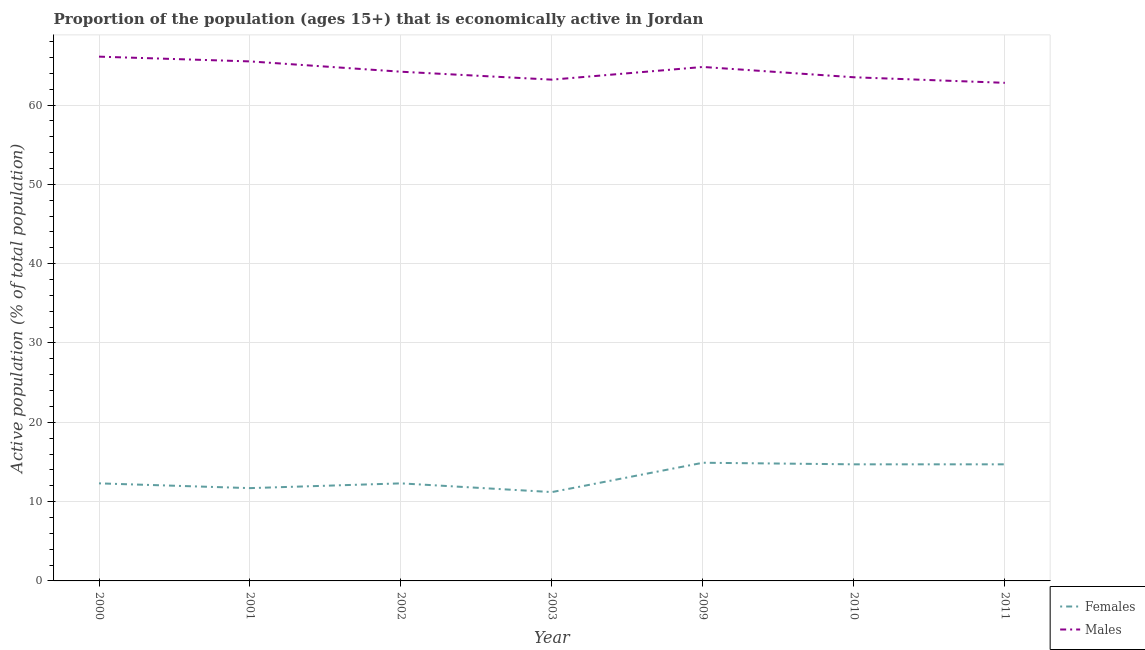How many different coloured lines are there?
Your answer should be compact. 2. What is the percentage of economically active female population in 2009?
Keep it short and to the point. 14.9. Across all years, what is the maximum percentage of economically active male population?
Give a very brief answer. 66.1. Across all years, what is the minimum percentage of economically active female population?
Offer a very short reply. 11.2. In which year was the percentage of economically active female population maximum?
Provide a succinct answer. 2009. What is the total percentage of economically active male population in the graph?
Ensure brevity in your answer.  450.1. What is the difference between the percentage of economically active male population in 2002 and that in 2011?
Offer a very short reply. 1.4. What is the difference between the percentage of economically active female population in 2011 and the percentage of economically active male population in 2009?
Offer a very short reply. -50.1. What is the average percentage of economically active male population per year?
Make the answer very short. 64.3. In the year 2009, what is the difference between the percentage of economically active female population and percentage of economically active male population?
Give a very brief answer. -49.9. What is the ratio of the percentage of economically active female population in 2000 to that in 2011?
Offer a terse response. 0.84. Is the difference between the percentage of economically active female population in 2009 and 2010 greater than the difference between the percentage of economically active male population in 2009 and 2010?
Your answer should be compact. No. What is the difference between the highest and the second highest percentage of economically active female population?
Your response must be concise. 0.2. What is the difference between the highest and the lowest percentage of economically active male population?
Offer a very short reply. 3.3. Is the sum of the percentage of economically active female population in 2000 and 2011 greater than the maximum percentage of economically active male population across all years?
Offer a terse response. No. Does the percentage of economically active female population monotonically increase over the years?
Offer a terse response. No. Is the percentage of economically active male population strictly greater than the percentage of economically active female population over the years?
Your answer should be very brief. Yes. Does the graph contain grids?
Ensure brevity in your answer.  Yes. Where does the legend appear in the graph?
Make the answer very short. Bottom right. How are the legend labels stacked?
Your response must be concise. Vertical. What is the title of the graph?
Make the answer very short. Proportion of the population (ages 15+) that is economically active in Jordan. Does "Start a business" appear as one of the legend labels in the graph?
Keep it short and to the point. No. What is the label or title of the Y-axis?
Give a very brief answer. Active population (% of total population). What is the Active population (% of total population) of Females in 2000?
Offer a very short reply. 12.3. What is the Active population (% of total population) in Males in 2000?
Your answer should be very brief. 66.1. What is the Active population (% of total population) of Females in 2001?
Your answer should be very brief. 11.7. What is the Active population (% of total population) of Males in 2001?
Make the answer very short. 65.5. What is the Active population (% of total population) of Females in 2002?
Provide a succinct answer. 12.3. What is the Active population (% of total population) in Males in 2002?
Your response must be concise. 64.2. What is the Active population (% of total population) in Females in 2003?
Your answer should be compact. 11.2. What is the Active population (% of total population) in Males in 2003?
Provide a short and direct response. 63.2. What is the Active population (% of total population) in Females in 2009?
Provide a succinct answer. 14.9. What is the Active population (% of total population) in Males in 2009?
Offer a terse response. 64.8. What is the Active population (% of total population) in Females in 2010?
Your answer should be very brief. 14.7. What is the Active population (% of total population) in Males in 2010?
Your response must be concise. 63.5. What is the Active population (% of total population) of Females in 2011?
Your answer should be very brief. 14.7. What is the Active population (% of total population) in Males in 2011?
Keep it short and to the point. 62.8. Across all years, what is the maximum Active population (% of total population) of Females?
Keep it short and to the point. 14.9. Across all years, what is the maximum Active population (% of total population) in Males?
Make the answer very short. 66.1. Across all years, what is the minimum Active population (% of total population) in Females?
Your answer should be compact. 11.2. Across all years, what is the minimum Active population (% of total population) of Males?
Your answer should be compact. 62.8. What is the total Active population (% of total population) in Females in the graph?
Give a very brief answer. 91.8. What is the total Active population (% of total population) in Males in the graph?
Your answer should be very brief. 450.1. What is the difference between the Active population (% of total population) of Males in 2000 and that in 2001?
Offer a very short reply. 0.6. What is the difference between the Active population (% of total population) of Males in 2000 and that in 2002?
Offer a terse response. 1.9. What is the difference between the Active population (% of total population) in Males in 2000 and that in 2003?
Keep it short and to the point. 2.9. What is the difference between the Active population (% of total population) in Females in 2000 and that in 2009?
Keep it short and to the point. -2.6. What is the difference between the Active population (% of total population) in Males in 2000 and that in 2009?
Your answer should be compact. 1.3. What is the difference between the Active population (% of total population) of Females in 2000 and that in 2011?
Ensure brevity in your answer.  -2.4. What is the difference between the Active population (% of total population) of Females in 2001 and that in 2002?
Keep it short and to the point. -0.6. What is the difference between the Active population (% of total population) of Males in 2001 and that in 2002?
Your answer should be compact. 1.3. What is the difference between the Active population (% of total population) of Females in 2001 and that in 2011?
Give a very brief answer. -3. What is the difference between the Active population (% of total population) in Males in 2001 and that in 2011?
Your response must be concise. 2.7. What is the difference between the Active population (% of total population) of Females in 2002 and that in 2003?
Your answer should be compact. 1.1. What is the difference between the Active population (% of total population) of Males in 2002 and that in 2003?
Ensure brevity in your answer.  1. What is the difference between the Active population (% of total population) of Females in 2002 and that in 2009?
Offer a terse response. -2.6. What is the difference between the Active population (% of total population) in Males in 2002 and that in 2010?
Keep it short and to the point. 0.7. What is the difference between the Active population (% of total population) in Males in 2002 and that in 2011?
Provide a succinct answer. 1.4. What is the difference between the Active population (% of total population) in Males in 2003 and that in 2009?
Provide a succinct answer. -1.6. What is the difference between the Active population (% of total population) of Males in 2003 and that in 2010?
Ensure brevity in your answer.  -0.3. What is the difference between the Active population (% of total population) of Males in 2003 and that in 2011?
Offer a terse response. 0.4. What is the difference between the Active population (% of total population) of Females in 2009 and that in 2010?
Your answer should be compact. 0.2. What is the difference between the Active population (% of total population) in Females in 2009 and that in 2011?
Keep it short and to the point. 0.2. What is the difference between the Active population (% of total population) of Males in 2009 and that in 2011?
Make the answer very short. 2. What is the difference between the Active population (% of total population) in Females in 2000 and the Active population (% of total population) in Males in 2001?
Keep it short and to the point. -53.2. What is the difference between the Active population (% of total population) of Females in 2000 and the Active population (% of total population) of Males in 2002?
Your answer should be compact. -51.9. What is the difference between the Active population (% of total population) in Females in 2000 and the Active population (% of total population) in Males in 2003?
Give a very brief answer. -50.9. What is the difference between the Active population (% of total population) in Females in 2000 and the Active population (% of total population) in Males in 2009?
Offer a terse response. -52.5. What is the difference between the Active population (% of total population) of Females in 2000 and the Active population (% of total population) of Males in 2010?
Your answer should be compact. -51.2. What is the difference between the Active population (% of total population) in Females in 2000 and the Active population (% of total population) in Males in 2011?
Keep it short and to the point. -50.5. What is the difference between the Active population (% of total population) in Females in 2001 and the Active population (% of total population) in Males in 2002?
Your answer should be very brief. -52.5. What is the difference between the Active population (% of total population) in Females in 2001 and the Active population (% of total population) in Males in 2003?
Provide a succinct answer. -51.5. What is the difference between the Active population (% of total population) in Females in 2001 and the Active population (% of total population) in Males in 2009?
Your answer should be compact. -53.1. What is the difference between the Active population (% of total population) of Females in 2001 and the Active population (% of total population) of Males in 2010?
Give a very brief answer. -51.8. What is the difference between the Active population (% of total population) in Females in 2001 and the Active population (% of total population) in Males in 2011?
Provide a short and direct response. -51.1. What is the difference between the Active population (% of total population) of Females in 2002 and the Active population (% of total population) of Males in 2003?
Keep it short and to the point. -50.9. What is the difference between the Active population (% of total population) of Females in 2002 and the Active population (% of total population) of Males in 2009?
Offer a very short reply. -52.5. What is the difference between the Active population (% of total population) of Females in 2002 and the Active population (% of total population) of Males in 2010?
Ensure brevity in your answer.  -51.2. What is the difference between the Active population (% of total population) in Females in 2002 and the Active population (% of total population) in Males in 2011?
Keep it short and to the point. -50.5. What is the difference between the Active population (% of total population) in Females in 2003 and the Active population (% of total population) in Males in 2009?
Provide a short and direct response. -53.6. What is the difference between the Active population (% of total population) of Females in 2003 and the Active population (% of total population) of Males in 2010?
Your answer should be very brief. -52.3. What is the difference between the Active population (% of total population) in Females in 2003 and the Active population (% of total population) in Males in 2011?
Offer a terse response. -51.6. What is the difference between the Active population (% of total population) in Females in 2009 and the Active population (% of total population) in Males in 2010?
Offer a very short reply. -48.6. What is the difference between the Active population (% of total population) in Females in 2009 and the Active population (% of total population) in Males in 2011?
Your response must be concise. -47.9. What is the difference between the Active population (% of total population) in Females in 2010 and the Active population (% of total population) in Males in 2011?
Provide a short and direct response. -48.1. What is the average Active population (% of total population) of Females per year?
Provide a short and direct response. 13.11. What is the average Active population (% of total population) of Males per year?
Ensure brevity in your answer.  64.3. In the year 2000, what is the difference between the Active population (% of total population) of Females and Active population (% of total population) of Males?
Provide a succinct answer. -53.8. In the year 2001, what is the difference between the Active population (% of total population) of Females and Active population (% of total population) of Males?
Offer a terse response. -53.8. In the year 2002, what is the difference between the Active population (% of total population) of Females and Active population (% of total population) of Males?
Your response must be concise. -51.9. In the year 2003, what is the difference between the Active population (% of total population) of Females and Active population (% of total population) of Males?
Your answer should be very brief. -52. In the year 2009, what is the difference between the Active population (% of total population) of Females and Active population (% of total population) of Males?
Provide a short and direct response. -49.9. In the year 2010, what is the difference between the Active population (% of total population) in Females and Active population (% of total population) in Males?
Your answer should be very brief. -48.8. In the year 2011, what is the difference between the Active population (% of total population) in Females and Active population (% of total population) in Males?
Offer a very short reply. -48.1. What is the ratio of the Active population (% of total population) in Females in 2000 to that in 2001?
Keep it short and to the point. 1.05. What is the ratio of the Active population (% of total population) of Males in 2000 to that in 2001?
Keep it short and to the point. 1.01. What is the ratio of the Active population (% of total population) in Females in 2000 to that in 2002?
Make the answer very short. 1. What is the ratio of the Active population (% of total population) of Males in 2000 to that in 2002?
Keep it short and to the point. 1.03. What is the ratio of the Active population (% of total population) of Females in 2000 to that in 2003?
Provide a succinct answer. 1.1. What is the ratio of the Active population (% of total population) of Males in 2000 to that in 2003?
Offer a very short reply. 1.05. What is the ratio of the Active population (% of total population) in Females in 2000 to that in 2009?
Provide a short and direct response. 0.83. What is the ratio of the Active population (% of total population) of Males in 2000 to that in 2009?
Provide a succinct answer. 1.02. What is the ratio of the Active population (% of total population) in Females in 2000 to that in 2010?
Your answer should be very brief. 0.84. What is the ratio of the Active population (% of total population) in Males in 2000 to that in 2010?
Your response must be concise. 1.04. What is the ratio of the Active population (% of total population) of Females in 2000 to that in 2011?
Your answer should be very brief. 0.84. What is the ratio of the Active population (% of total population) in Males in 2000 to that in 2011?
Provide a short and direct response. 1.05. What is the ratio of the Active population (% of total population) in Females in 2001 to that in 2002?
Provide a short and direct response. 0.95. What is the ratio of the Active population (% of total population) in Males in 2001 to that in 2002?
Provide a succinct answer. 1.02. What is the ratio of the Active population (% of total population) in Females in 2001 to that in 2003?
Ensure brevity in your answer.  1.04. What is the ratio of the Active population (% of total population) in Males in 2001 to that in 2003?
Your answer should be very brief. 1.04. What is the ratio of the Active population (% of total population) of Females in 2001 to that in 2009?
Offer a terse response. 0.79. What is the ratio of the Active population (% of total population) of Males in 2001 to that in 2009?
Offer a terse response. 1.01. What is the ratio of the Active population (% of total population) of Females in 2001 to that in 2010?
Your response must be concise. 0.8. What is the ratio of the Active population (% of total population) in Males in 2001 to that in 2010?
Your answer should be compact. 1.03. What is the ratio of the Active population (% of total population) in Females in 2001 to that in 2011?
Keep it short and to the point. 0.8. What is the ratio of the Active population (% of total population) in Males in 2001 to that in 2011?
Your response must be concise. 1.04. What is the ratio of the Active population (% of total population) in Females in 2002 to that in 2003?
Offer a terse response. 1.1. What is the ratio of the Active population (% of total population) of Males in 2002 to that in 2003?
Your answer should be compact. 1.02. What is the ratio of the Active population (% of total population) in Females in 2002 to that in 2009?
Offer a very short reply. 0.83. What is the ratio of the Active population (% of total population) in Females in 2002 to that in 2010?
Provide a short and direct response. 0.84. What is the ratio of the Active population (% of total population) in Males in 2002 to that in 2010?
Give a very brief answer. 1.01. What is the ratio of the Active population (% of total population) in Females in 2002 to that in 2011?
Your answer should be very brief. 0.84. What is the ratio of the Active population (% of total population) of Males in 2002 to that in 2011?
Ensure brevity in your answer.  1.02. What is the ratio of the Active population (% of total population) of Females in 2003 to that in 2009?
Give a very brief answer. 0.75. What is the ratio of the Active population (% of total population) of Males in 2003 to that in 2009?
Make the answer very short. 0.98. What is the ratio of the Active population (% of total population) of Females in 2003 to that in 2010?
Your answer should be compact. 0.76. What is the ratio of the Active population (% of total population) in Females in 2003 to that in 2011?
Your response must be concise. 0.76. What is the ratio of the Active population (% of total population) in Males in 2003 to that in 2011?
Your response must be concise. 1.01. What is the ratio of the Active population (% of total population) in Females in 2009 to that in 2010?
Offer a terse response. 1.01. What is the ratio of the Active population (% of total population) in Males in 2009 to that in 2010?
Provide a short and direct response. 1.02. What is the ratio of the Active population (% of total population) in Females in 2009 to that in 2011?
Make the answer very short. 1.01. What is the ratio of the Active population (% of total population) of Males in 2009 to that in 2011?
Make the answer very short. 1.03. What is the ratio of the Active population (% of total population) of Males in 2010 to that in 2011?
Your answer should be compact. 1.01. What is the difference between the highest and the second highest Active population (% of total population) of Females?
Make the answer very short. 0.2. What is the difference between the highest and the lowest Active population (% of total population) of Males?
Offer a terse response. 3.3. 